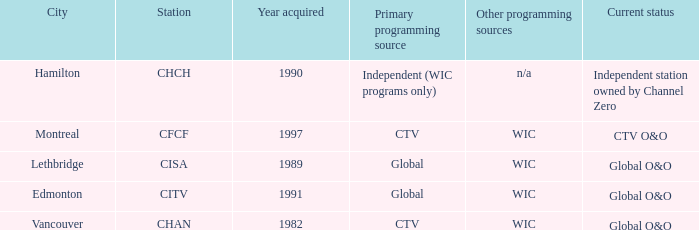Could you parse the entire table? {'header': ['City', 'Station', 'Year acquired', 'Primary programming source', 'Other programming sources', 'Current status'], 'rows': [['Hamilton', 'CHCH', '1990', 'Independent (WIC programs only)', 'n/a', 'Independent station owned by Channel Zero'], ['Montreal', 'CFCF', '1997', 'CTV', 'WIC', 'CTV O&O'], ['Lethbridge', 'CISA', '1989', 'Global', 'WIC', 'Global O&O'], ['Edmonton', 'CITV', '1991', 'Global', 'WIC', 'Global O&O'], ['Vancouver', 'CHAN', '1982', 'CTV', 'WIC', 'Global O&O']]} How any were gained as the chan 1.0. 